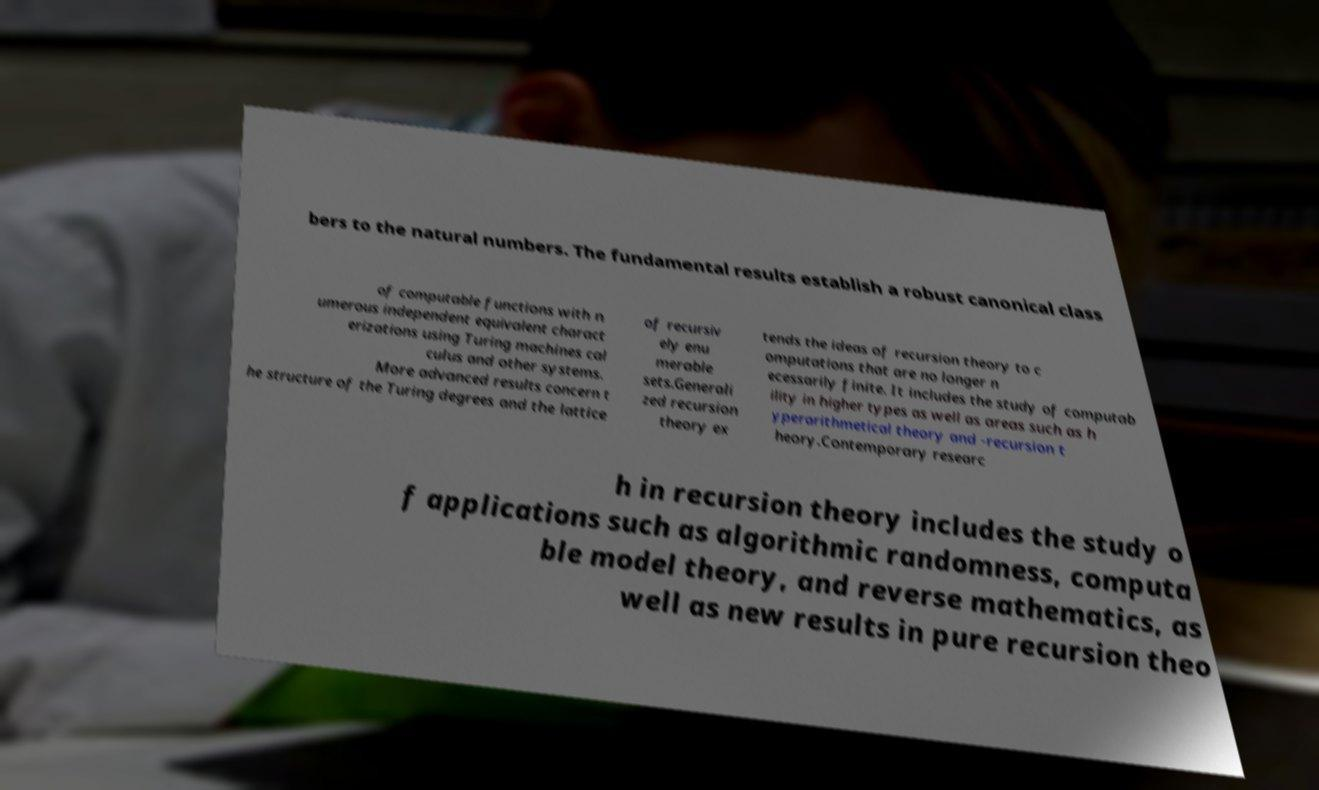Can you accurately transcribe the text from the provided image for me? bers to the natural numbers. The fundamental results establish a robust canonical class of computable functions with n umerous independent equivalent charact erizations using Turing machines cal culus and other systems. More advanced results concern t he structure of the Turing degrees and the lattice of recursiv ely enu merable sets.Generali zed recursion theory ex tends the ideas of recursion theory to c omputations that are no longer n ecessarily finite. It includes the study of computab ility in higher types as well as areas such as h yperarithmetical theory and -recursion t heory.Contemporary researc h in recursion theory includes the study o f applications such as algorithmic randomness, computa ble model theory, and reverse mathematics, as well as new results in pure recursion theo 